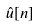Convert formula to latex. <formula><loc_0><loc_0><loc_500><loc_500>\hat { u } [ n ]</formula> 